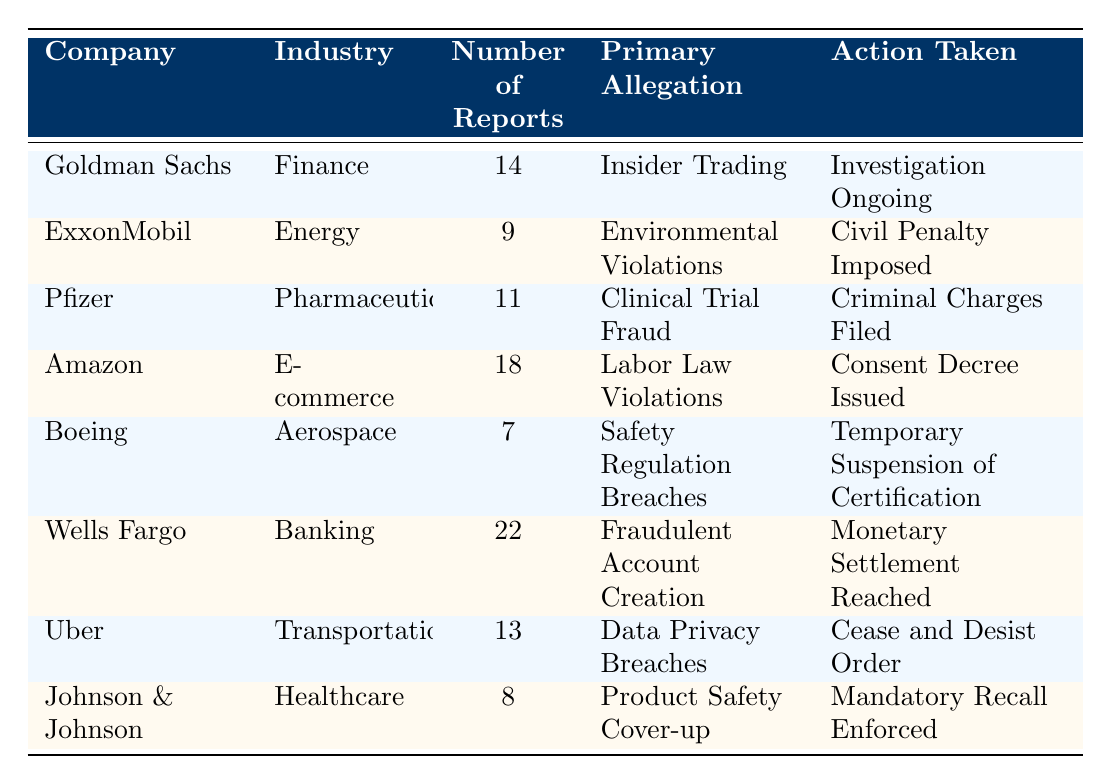What is the primary allegation against Wells Fargo? According to the table, the primary allegation against Wells Fargo is "Fraudulent Account Creation." This information is directly listed in the row corresponding to Wells Fargo.
Answer: Fraudulent Account Creation Which company had the highest number of whistleblower reports? The company with the highest number of reports is Wells Fargo, which received 22 reports. This can be identified by comparing the "Number of Reports" column for each company.
Answer: Wells Fargo How many reports were received for companies in the Pharmaceuticals industry? The companies in the Pharmaceuticals industry are Pfizer, which received 11 reports. The number of reports for this industry can be summed directly from the table.
Answer: 11 Is it true that Amazon faced allegations related to safety regulations? No, this statement is false as Amazon's primary allegation is related to "Labor Law Violations," not safety regulations. This can be found by referencing the corresponding row for Amazon in the table.
Answer: No What is the average number of reports across all companies in the table? First, sum the number of reports from each company: 14 (Goldman Sachs) + 9 (ExxonMobil) + 11 (Pfizer) + 18 (Amazon) + 7 (Boeing) + 22 (Wells Fargo) + 13 (Uber) + 8 (Johnson & Johnson) = 102. There are 8 companies, so the average is 102/8 = 12.75.
Answer: 12.75 Which industries have companies that faced criminal charges? The only company that faced criminal charges is Pfizer in the Pharmaceuticals industry. This is determined by examining the "Action Taken" column for each company, identifying which action was "Criminal Charges Filed."
Answer: Pharmaceuticals How many companies in the table had ongoing investigations? Only one company, Goldman Sachs, has an ongoing investigation according to the "Action Taken" column, which states "Investigation Ongoing." This requires simply checking the relevant cell in the table.
Answer: 1 Which company faced a temporary suspension of certification, and what was the primary allegation? Boeing faced a temporary suspension of certification, with the primary allegation being "Safety Regulation Breaches." This information can be extracted directly from the row that contains Boeing's data.
Answer: Boeing, Safety Regulation Breaches 